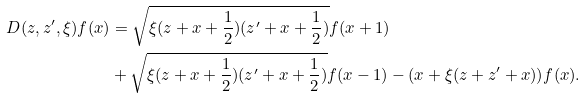Convert formula to latex. <formula><loc_0><loc_0><loc_500><loc_500>D ( z , z ^ { \prime } , \xi ) f ( x ) & = \sqrt { \xi ( z + x + \frac { 1 } { 2 } ) ( z ^ { \prime } + x + \frac { 1 } { 2 } ) } f ( x + 1 ) \\ & + \sqrt { \xi ( z + x + \frac { 1 } { 2 } ) ( z ^ { \prime } + x + \frac { 1 } { 2 } ) } f ( x - 1 ) - ( x + \xi ( z + z ^ { \prime } + x ) ) f ( x ) .</formula> 